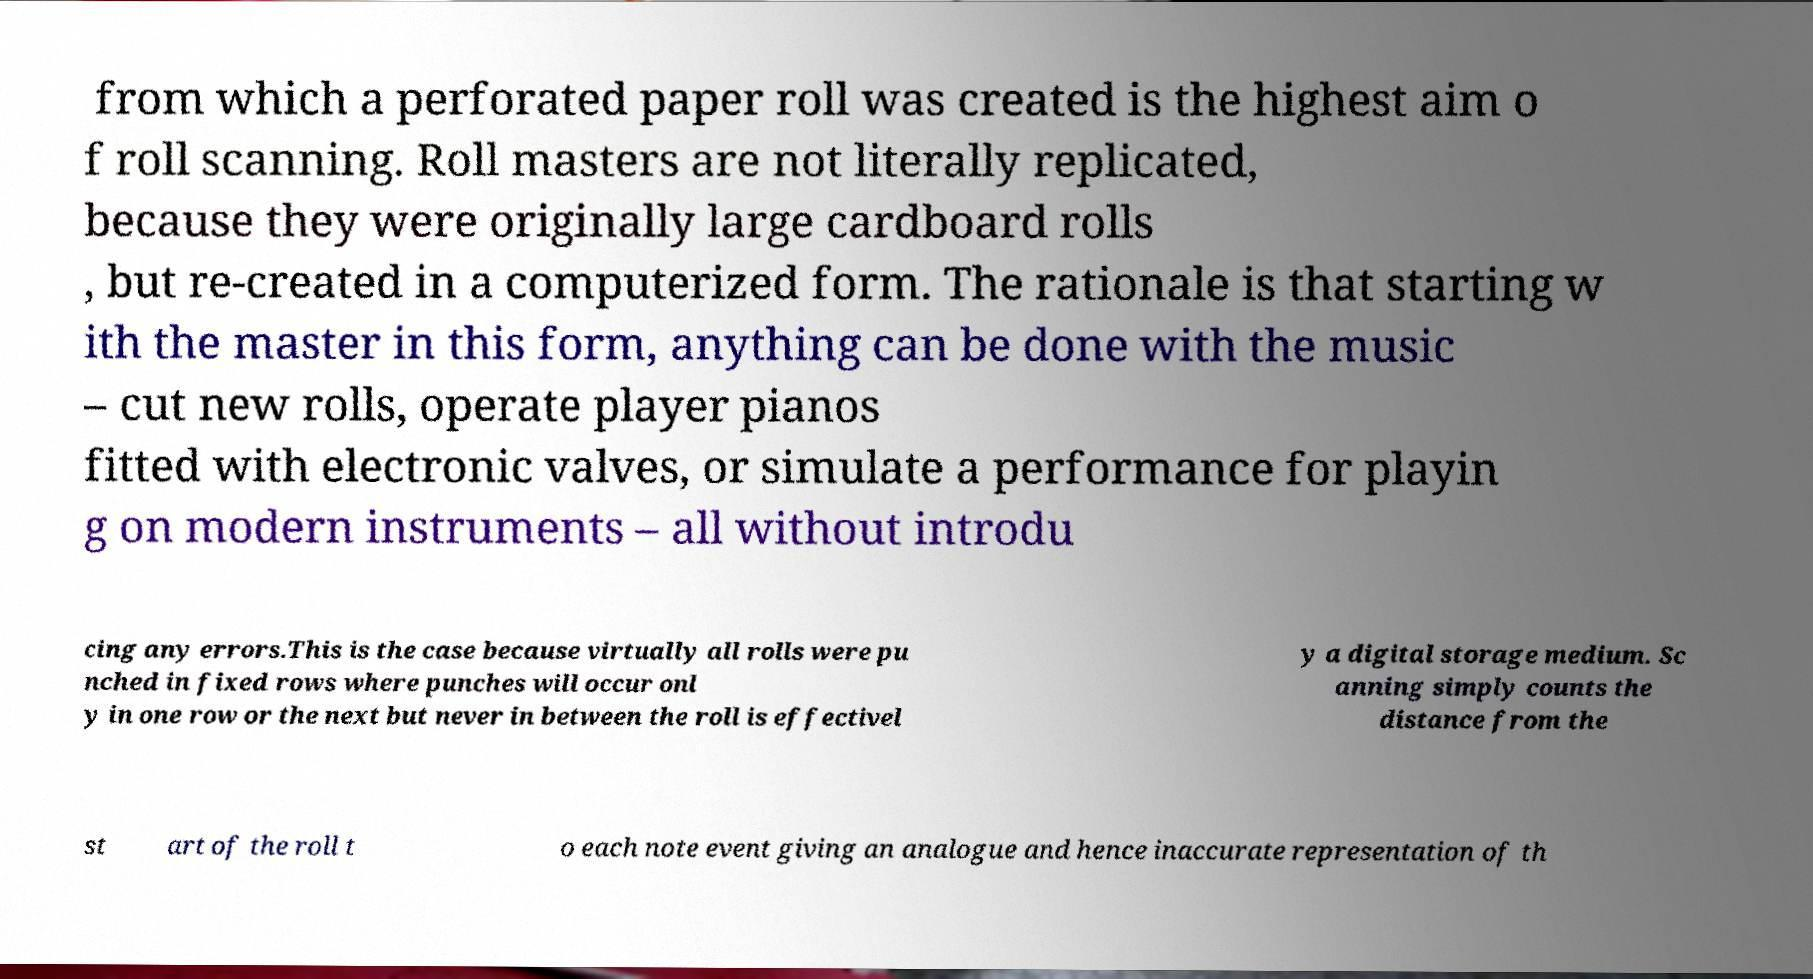I need the written content from this picture converted into text. Can you do that? from which a perforated paper roll was created is the highest aim o f roll scanning. Roll masters are not literally replicated, because they were originally large cardboard rolls , but re-created in a computerized form. The rationale is that starting w ith the master in this form, anything can be done with the music – cut new rolls, operate player pianos fitted with electronic valves, or simulate a performance for playin g on modern instruments – all without introdu cing any errors.This is the case because virtually all rolls were pu nched in fixed rows where punches will occur onl y in one row or the next but never in between the roll is effectivel y a digital storage medium. Sc anning simply counts the distance from the st art of the roll t o each note event giving an analogue and hence inaccurate representation of th 